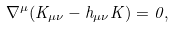<formula> <loc_0><loc_0><loc_500><loc_500>\nabla ^ { \mu } ( K _ { \mu \nu } - h _ { \mu \nu } K ) = 0 ,</formula> 